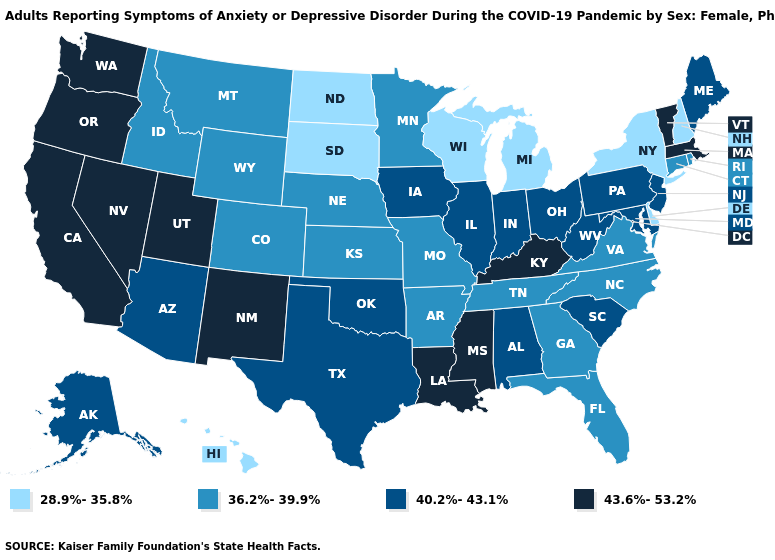Name the states that have a value in the range 40.2%-43.1%?
Short answer required. Alabama, Alaska, Arizona, Illinois, Indiana, Iowa, Maine, Maryland, New Jersey, Ohio, Oklahoma, Pennsylvania, South Carolina, Texas, West Virginia. Does Kentucky have the highest value in the USA?
Quick response, please. Yes. Among the states that border Massachusetts , which have the lowest value?
Quick response, please. New Hampshire, New York. Name the states that have a value in the range 28.9%-35.8%?
Write a very short answer. Delaware, Hawaii, Michigan, New Hampshire, New York, North Dakota, South Dakota, Wisconsin. What is the value of New Mexico?
Short answer required. 43.6%-53.2%. What is the lowest value in the MidWest?
Be succinct. 28.9%-35.8%. Name the states that have a value in the range 36.2%-39.9%?
Concise answer only. Arkansas, Colorado, Connecticut, Florida, Georgia, Idaho, Kansas, Minnesota, Missouri, Montana, Nebraska, North Carolina, Rhode Island, Tennessee, Virginia, Wyoming. What is the highest value in states that border Indiana?
Write a very short answer. 43.6%-53.2%. Name the states that have a value in the range 36.2%-39.9%?
Be succinct. Arkansas, Colorado, Connecticut, Florida, Georgia, Idaho, Kansas, Minnesota, Missouri, Montana, Nebraska, North Carolina, Rhode Island, Tennessee, Virginia, Wyoming. Which states have the lowest value in the USA?
Write a very short answer. Delaware, Hawaii, Michigan, New Hampshire, New York, North Dakota, South Dakota, Wisconsin. Does Mississippi have the highest value in the USA?
Give a very brief answer. Yes. What is the highest value in states that border Michigan?
Write a very short answer. 40.2%-43.1%. What is the highest value in states that border Oklahoma?
Be succinct. 43.6%-53.2%. Does South Dakota have the lowest value in the USA?
Short answer required. Yes. Which states hav the highest value in the Northeast?
Quick response, please. Massachusetts, Vermont. 